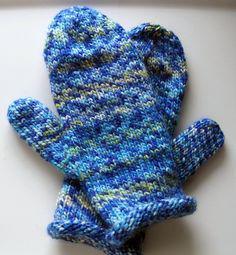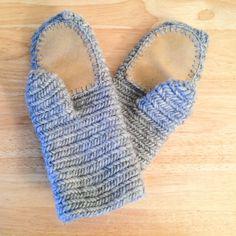The first image is the image on the left, the second image is the image on the right. Evaluate the accuracy of this statement regarding the images: "The left image contains a human wearing blue gloves that have the finger tips cut off.". Is it true? Answer yes or no. No. The first image is the image on the left, the second image is the image on the right. For the images displayed, is the sentence "A pair of gloves is being worn on a set of hands in the image on the left." factually correct? Answer yes or no. No. 